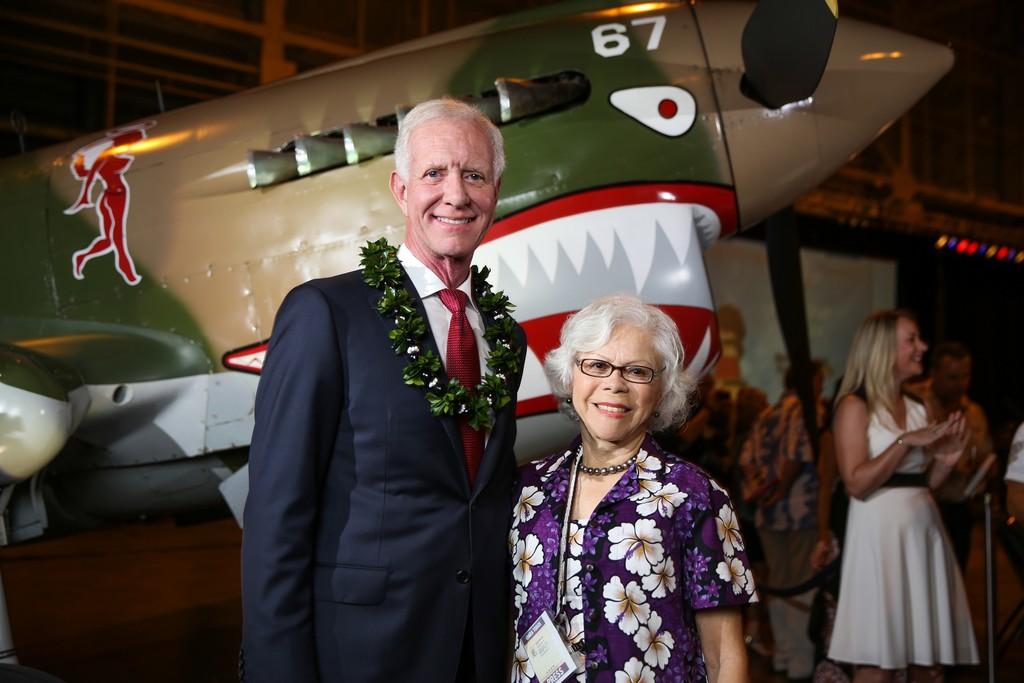What number is on the plane?
Your answer should be very brief. 67. 